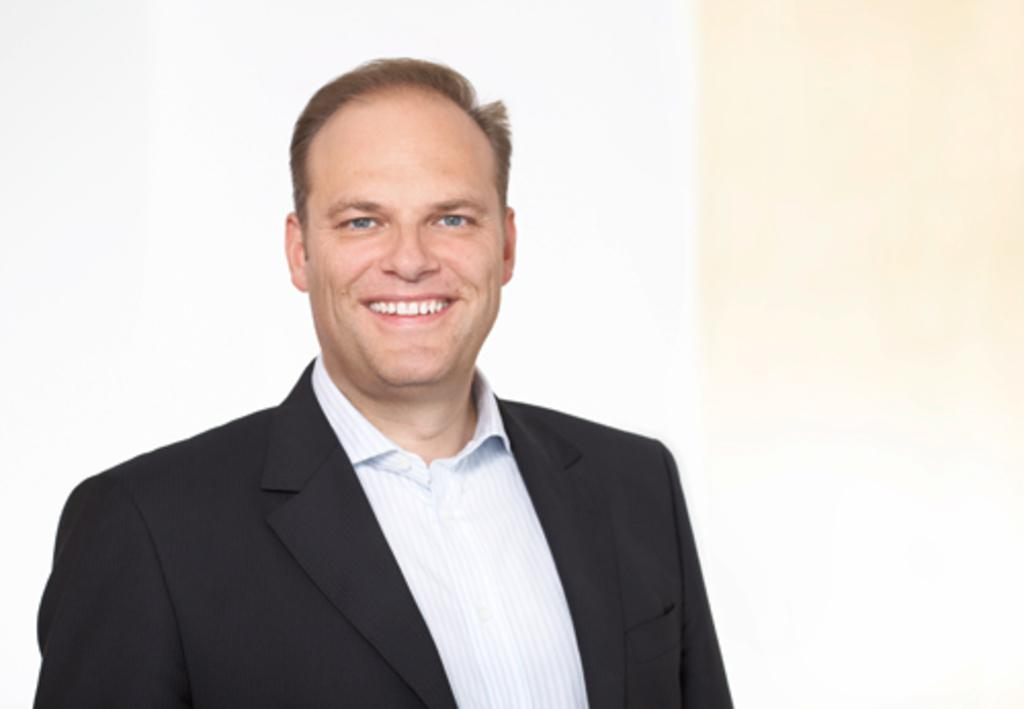What is the man in the image doing? The man is standing in the image. What expression does the man have on his face? The man is smiling. What type of clothing is the man wearing? The man is wearing a shirt and a suit. What color is the background of the image? The background of the image appears to be white in color. What type of zebra can be seen interacting with the man in the image? There is no zebra present in the image; it only features a man standing and smiling. What color is the ink used to write the man's name on his shirt? There is no name written on the man's shirt in the image, so we cannot determine the color of the ink. 